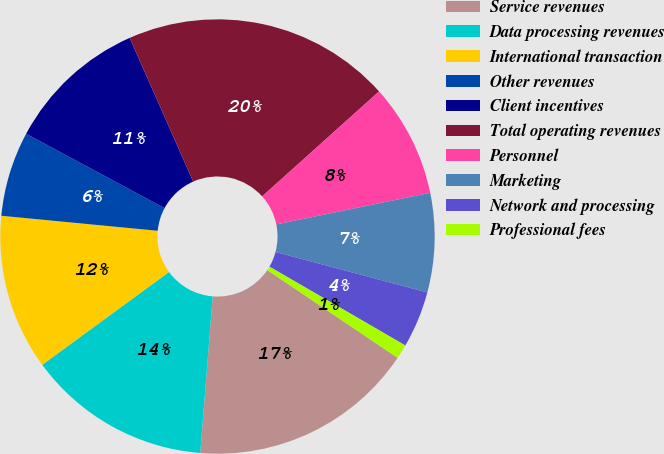Convert chart. <chart><loc_0><loc_0><loc_500><loc_500><pie_chart><fcel>Service revenues<fcel>Data processing revenues<fcel>International transaction<fcel>Other revenues<fcel>Client incentives<fcel>Total operating revenues<fcel>Personnel<fcel>Marketing<fcel>Network and processing<fcel>Professional fees<nl><fcel>16.83%<fcel>13.68%<fcel>11.58%<fcel>6.32%<fcel>10.53%<fcel>19.98%<fcel>8.42%<fcel>7.37%<fcel>4.22%<fcel>1.07%<nl></chart> 